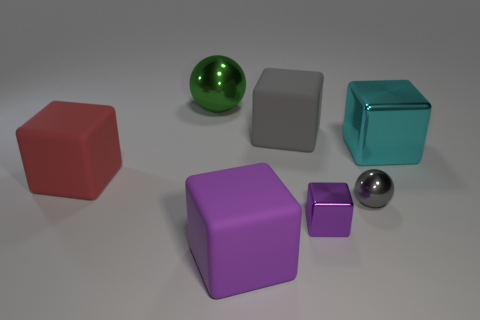Subtract 3 blocks. How many blocks are left? 2 Subtract all gray cubes. How many cubes are left? 4 Subtract all big cyan cubes. How many cubes are left? 4 Subtract all blue blocks. Subtract all cyan cylinders. How many blocks are left? 5 Add 2 large cyan blocks. How many objects exist? 9 Subtract all balls. How many objects are left? 5 Add 4 big purple spheres. How many big purple spheres exist? 4 Subtract 0 green cylinders. How many objects are left? 7 Subtract all small metal objects. Subtract all metallic objects. How many objects are left? 1 Add 2 green spheres. How many green spheres are left? 3 